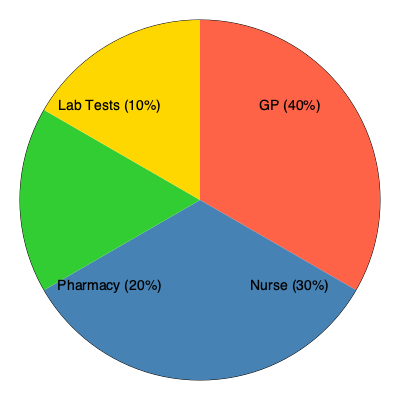Based on the pie chart showing wait times for different services at Belmont Hill Surgery, which service has the shortest average wait time, and what percentage of the total wait time does it represent? To answer this question, we need to analyze the pie chart:

1. The pie chart is divided into four sections, each representing a different service at Belmont Hill Surgery.

2. The services and their corresponding percentages are:
   - GP: 40%
   - Nurse: 30%
   - Pharmacy: 20%
   - Lab Tests: 10%

3. The percentages represent the proportion of total wait time for each service.

4. A smaller percentage indicates a shorter average wait time.

5. Comparing the percentages:
   40% > 30% > 20% > 10%

6. The smallest percentage is 10%, which corresponds to Lab Tests.

Therefore, Lab Tests have the shortest average wait time, representing 10% of the total wait time at Belmont Hill Surgery.
Answer: Lab Tests, 10% 